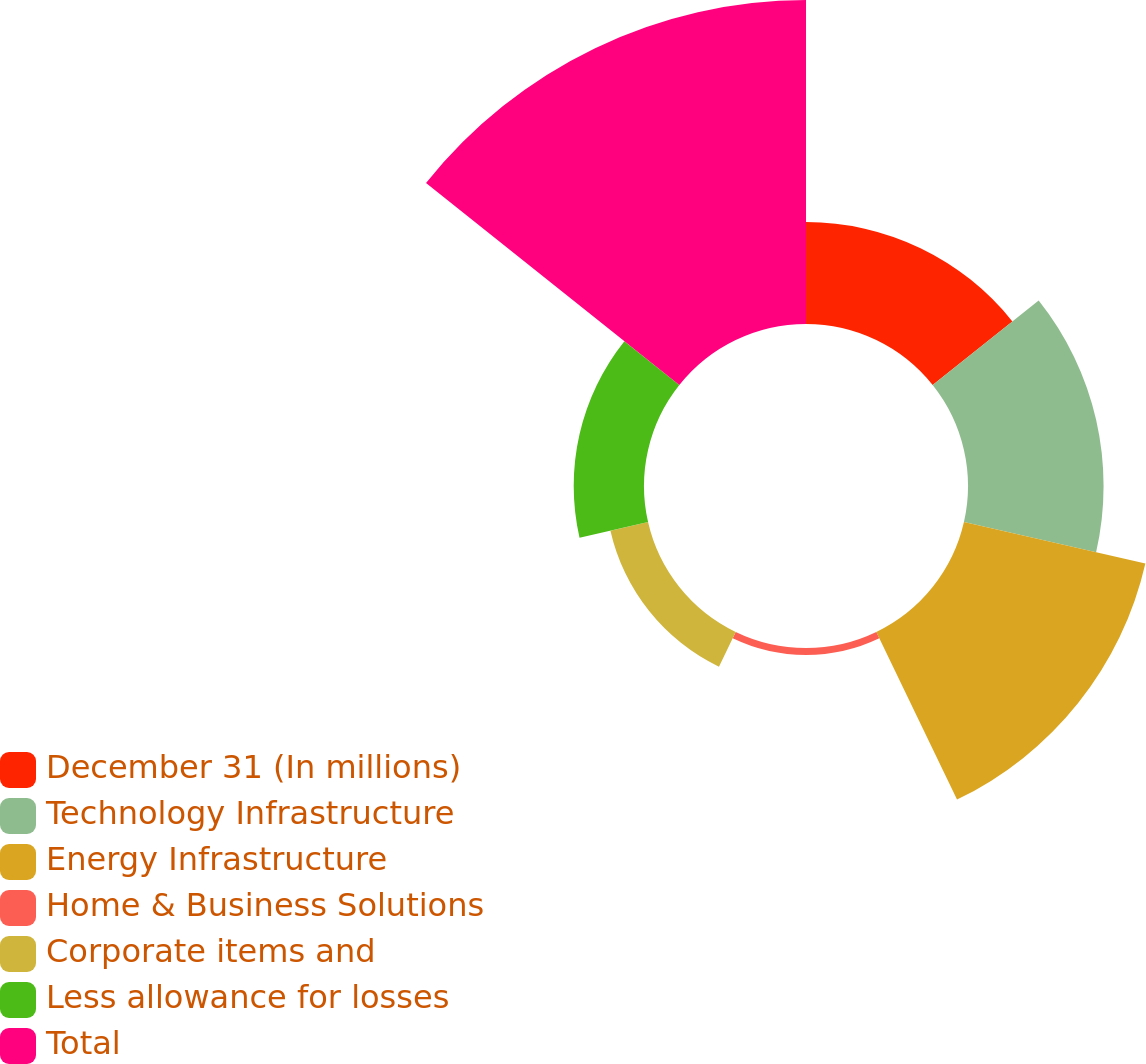Convert chart. <chart><loc_0><loc_0><loc_500><loc_500><pie_chart><fcel>December 31 (In millions)<fcel>Technology Infrastructure<fcel>Energy Infrastructure<fcel>Home & Business Solutions<fcel>Corporate items and<fcel>Less allowance for losses<fcel>Total<nl><fcel>11.81%<fcel>15.7%<fcel>21.55%<fcel>0.8%<fcel>4.47%<fcel>8.14%<fcel>37.52%<nl></chart> 